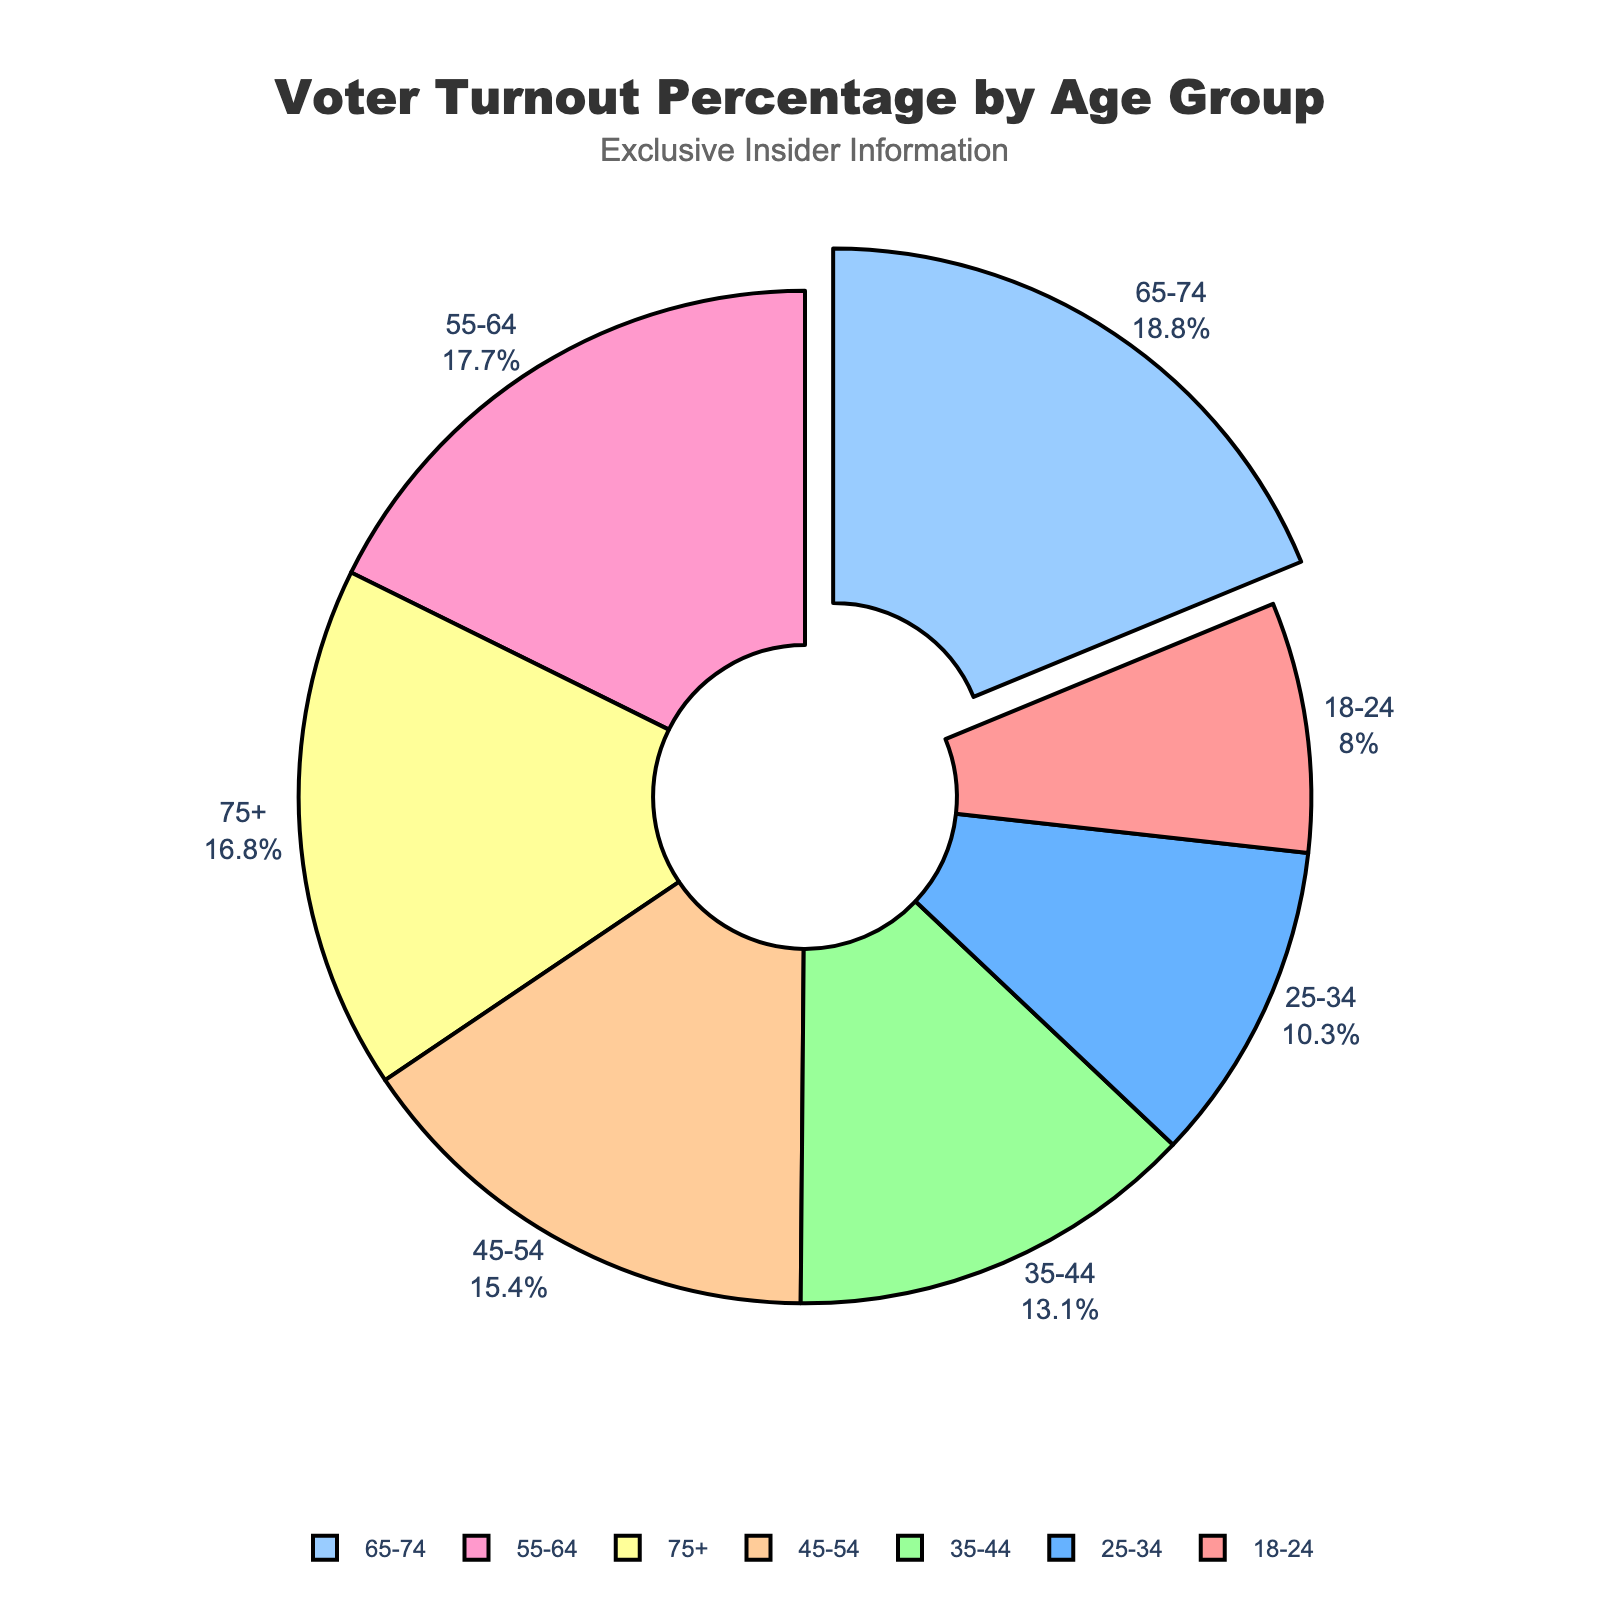What age group had the highest voter turnout percentage? From the figure, the age group with the highest voter turnout can be identified by looking at the section of the pie chart that is slightly pulled out from the rest. This section represents the age group 65-74.
Answer: 65-74 Which age group had the lowest voter turnout percentage? To determine the lowest voter turnout, look for the smallest slice in the pie chart. This corresponds to the age group 18-24.
Answer: 18-24 How much higher is the voter turnout percentage for ages 55-64 compared to 18-24? The voter turnout for 55-64 is 71.9%, and for 18-24, it is 32.5%. The difference is calculated as 71.9% - 32.5%.
Answer: 39.4% What is the combined voter turnout percentage for ages 18-24 and 25-34? Add the voter turnout percentages for the age groups 18-24 and 25-34: 32.5% + 41.8%.
Answer: 74.3% Which age group has a voter turnout percentage closest to 50%? Look for the age group whose voter turnout percentage is nearest to 50%. The age group 35-44 has a turnout of 53.2%, which is closest to 50%.
Answer: 35-44 Is the voter turnout percentage for ages 75+ higher or lower than for ages 45-54? Compare the voter turnout percentage for ages 75+ (68.1%) with that for ages 45-54 (62.7%). Since 68.1% is greater than 62.7%, the voter turnout for ages 75+ is higher.
Answer: Higher What is the average voter turnout percentage for all age groups? To find the average, add all the voter turnout percentages and then divide by the number of age groups. The sum is 32.5 + 41.8 + 53.2 + 62.7 + 71.9 + 76.3 + 68.1 = 406.5. Divide this by 7 (the number of age groups): 406.5 / 7.
Answer: 58.07% 